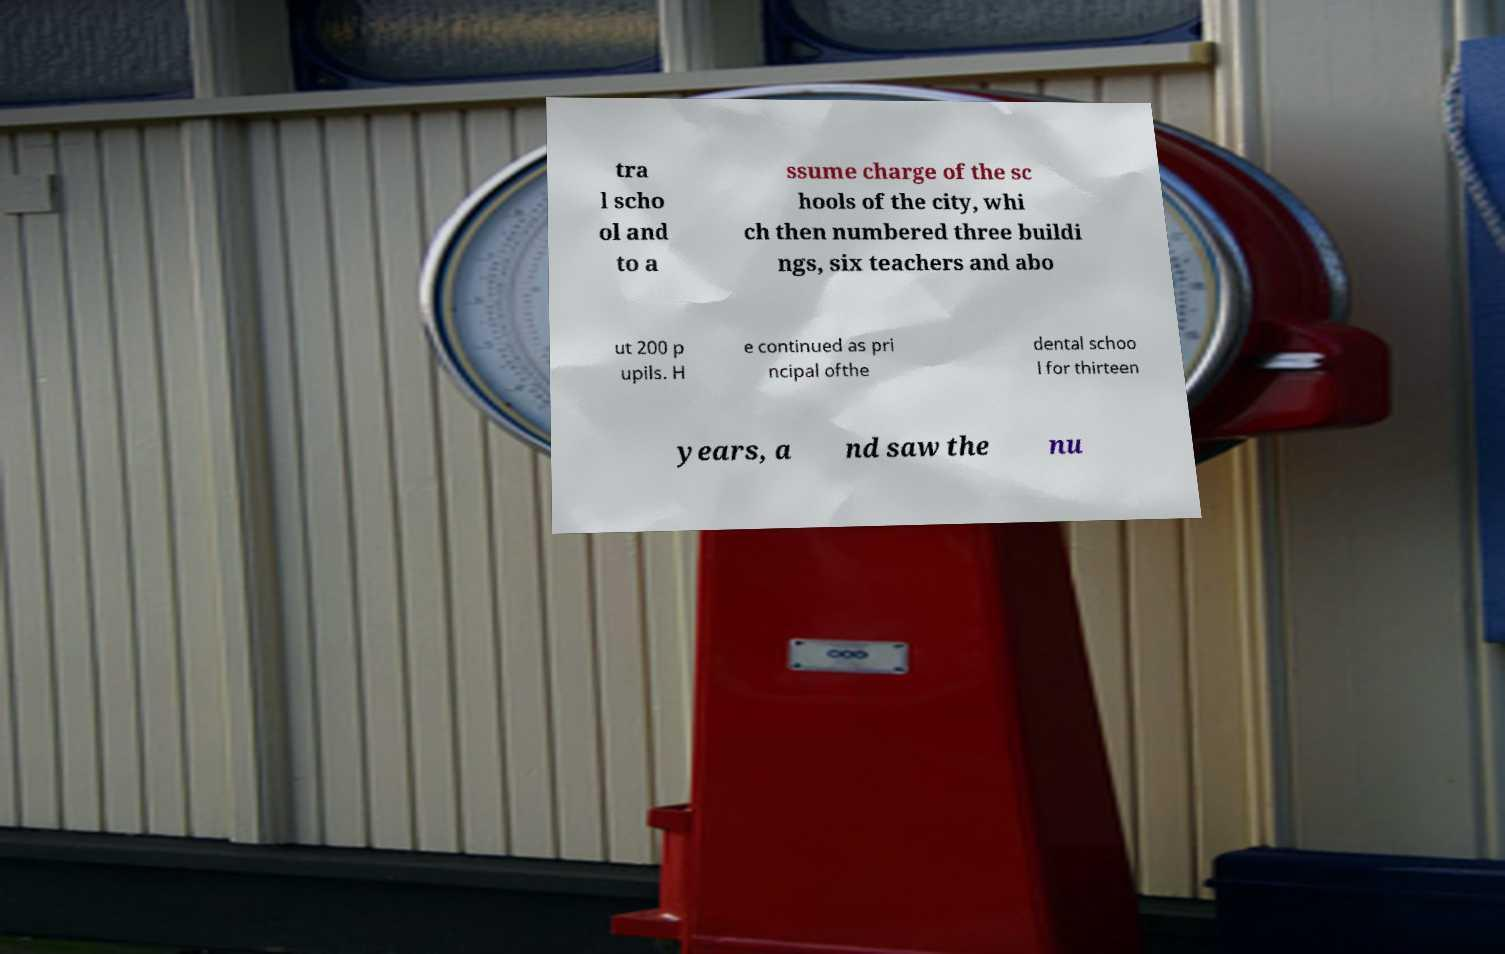There's text embedded in this image that I need extracted. Can you transcribe it verbatim? tra l scho ol and to a ssume charge of the sc hools of the city, whi ch then numbered three buildi ngs, six teachers and abo ut 200 p upils. H e continued as pri ncipal ofthe dental schoo l for thirteen years, a nd saw the nu 